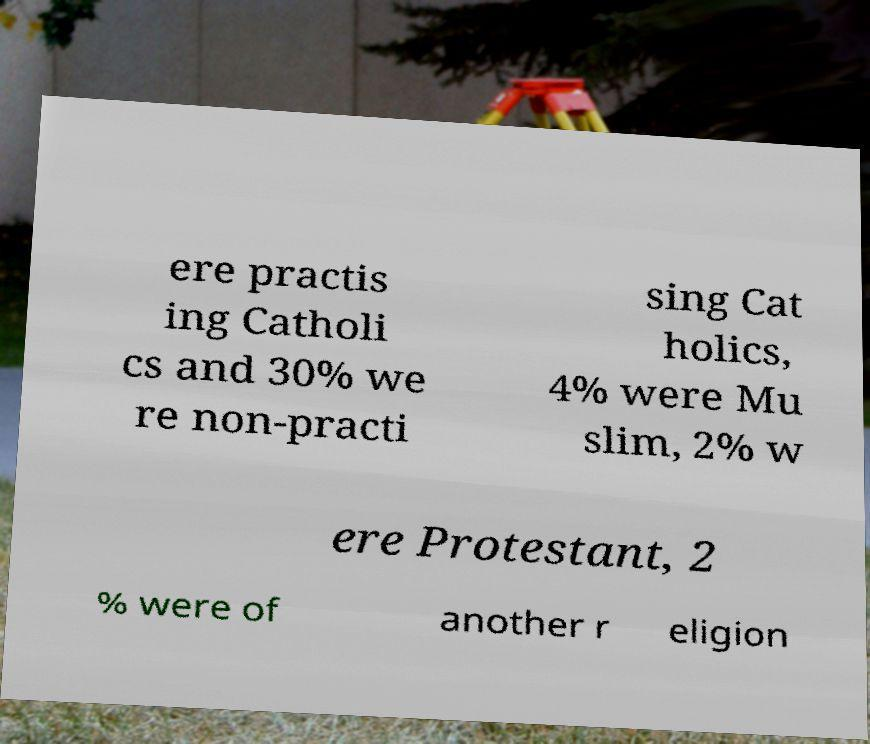Please identify and transcribe the text found in this image. ere practis ing Catholi cs and 30% we re non-practi sing Cat holics, 4% were Mu slim, 2% w ere Protestant, 2 % were of another r eligion 